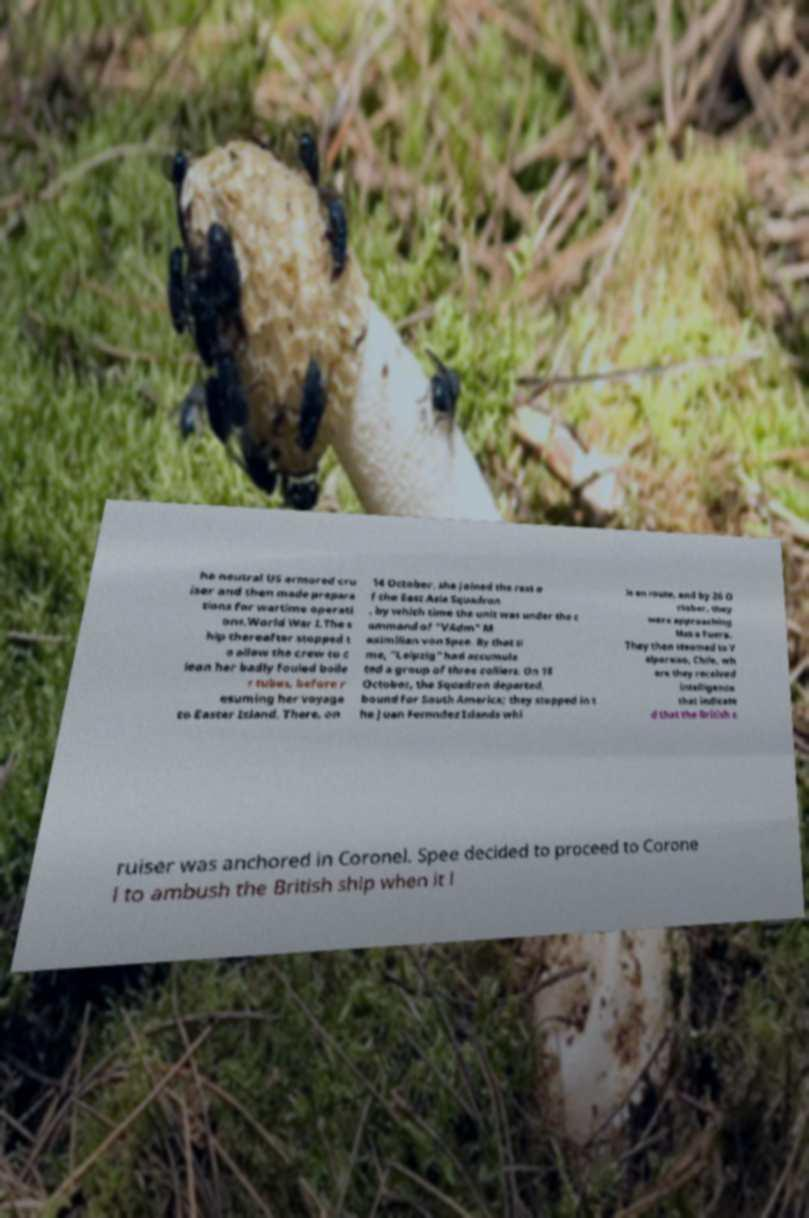Could you assist in decoding the text presented in this image and type it out clearly? he neutral US armored cru iser and then made prepara tions for wartime operati ons.World War I.The s hip thereafter stopped t o allow the crew to c lean her badly fouled boile r tubes, before r esuming her voyage to Easter Island. There, on 14 October, she joined the rest o f the East Asia Squadron , by which time the unit was under the c ommand of "VAdm" M aximilian von Spee. By that ti me, "Leipzig" had accumula ted a group of three colliers. On 18 October, the Squadron departed, bound for South America; they stopped in t he Juan Fernndez Islands whi le en route, and by 26 O ctober, they were approaching Mas a Fuera. They then steamed to V alparaiso, Chile, wh ere they received intelligence that indicate d that the British c ruiser was anchored in Coronel. Spee decided to proceed to Corone l to ambush the British ship when it l 